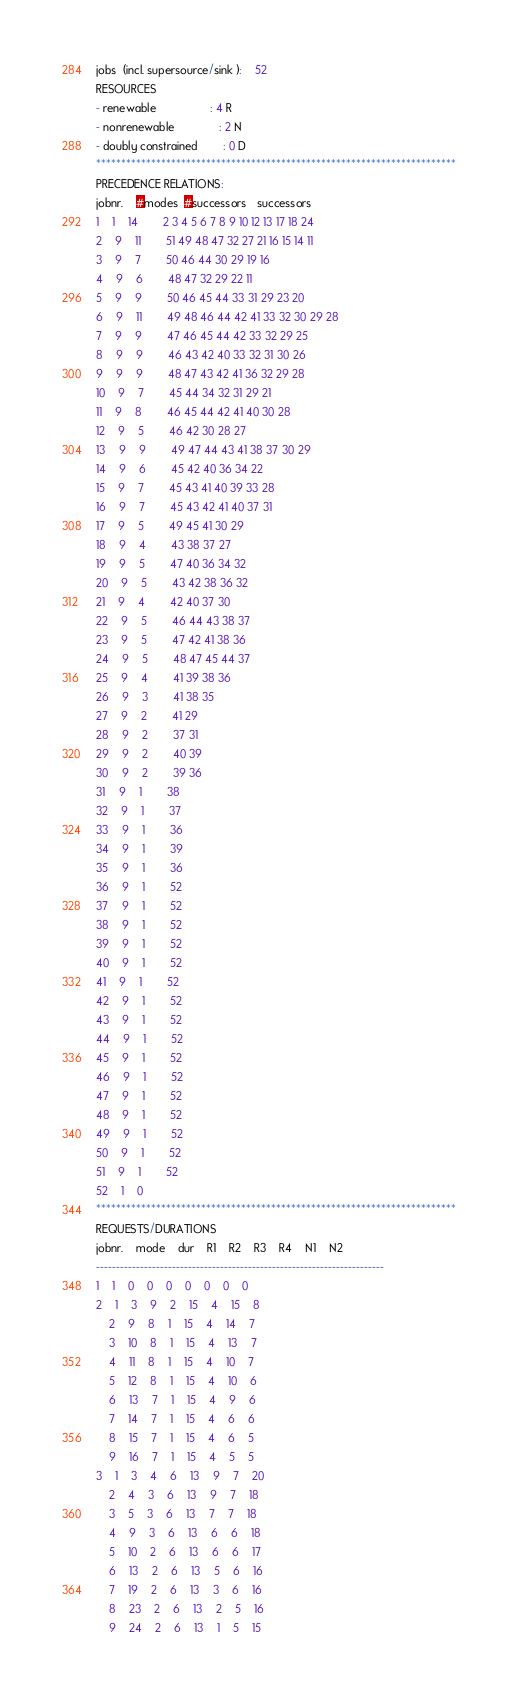Convert code to text. <code><loc_0><loc_0><loc_500><loc_500><_ObjectiveC_>jobs  (incl. supersource/sink ):	52
RESOURCES
- renewable                 : 4 R
- nonrenewable              : 2 N
- doubly constrained        : 0 D
************************************************************************
PRECEDENCE RELATIONS:
jobnr.    #modes  #successors   successors
1	1	14		2 3 4 5 6 7 8 9 10 12 13 17 18 24 
2	9	11		51 49 48 47 32 27 21 16 15 14 11 
3	9	7		50 46 44 30 29 19 16 
4	9	6		48 47 32 29 22 11 
5	9	9		50 46 45 44 33 31 29 23 20 
6	9	11		49 48 46 44 42 41 33 32 30 29 28 
7	9	9		47 46 45 44 42 33 32 29 25 
8	9	9		46 43 42 40 33 32 31 30 26 
9	9	9		48 47 43 42 41 36 32 29 28 
10	9	7		45 44 34 32 31 29 21 
11	9	8		46 45 44 42 41 40 30 28 
12	9	5		46 42 30 28 27 
13	9	9		49 47 44 43 41 38 37 30 29 
14	9	6		45 42 40 36 34 22 
15	9	7		45 43 41 40 39 33 28 
16	9	7		45 43 42 41 40 37 31 
17	9	5		49 45 41 30 29 
18	9	4		43 38 37 27 
19	9	5		47 40 36 34 32 
20	9	5		43 42 38 36 32 
21	9	4		42 40 37 30 
22	9	5		46 44 43 38 37 
23	9	5		47 42 41 38 36 
24	9	5		48 47 45 44 37 
25	9	4		41 39 38 36 
26	9	3		41 38 35 
27	9	2		41 29 
28	9	2		37 31 
29	9	2		40 39 
30	9	2		39 36 
31	9	1		38 
32	9	1		37 
33	9	1		36 
34	9	1		39 
35	9	1		36 
36	9	1		52 
37	9	1		52 
38	9	1		52 
39	9	1		52 
40	9	1		52 
41	9	1		52 
42	9	1		52 
43	9	1		52 
44	9	1		52 
45	9	1		52 
46	9	1		52 
47	9	1		52 
48	9	1		52 
49	9	1		52 
50	9	1		52 
51	9	1		52 
52	1	0		
************************************************************************
REQUESTS/DURATIONS
jobnr.	mode	dur	R1	R2	R3	R4	N1	N2	
------------------------------------------------------------------------
1	1	0	0	0	0	0	0	0	
2	1	3	9	2	15	4	15	8	
	2	9	8	1	15	4	14	7	
	3	10	8	1	15	4	13	7	
	4	11	8	1	15	4	10	7	
	5	12	8	1	15	4	10	6	
	6	13	7	1	15	4	9	6	
	7	14	7	1	15	4	6	6	
	8	15	7	1	15	4	6	5	
	9	16	7	1	15	4	5	5	
3	1	3	4	6	13	9	7	20	
	2	4	3	6	13	9	7	18	
	3	5	3	6	13	7	7	18	
	4	9	3	6	13	6	6	18	
	5	10	2	6	13	6	6	17	
	6	13	2	6	13	5	6	16	
	7	19	2	6	13	3	6	16	
	8	23	2	6	13	2	5	16	
	9	24	2	6	13	1	5	15	</code> 